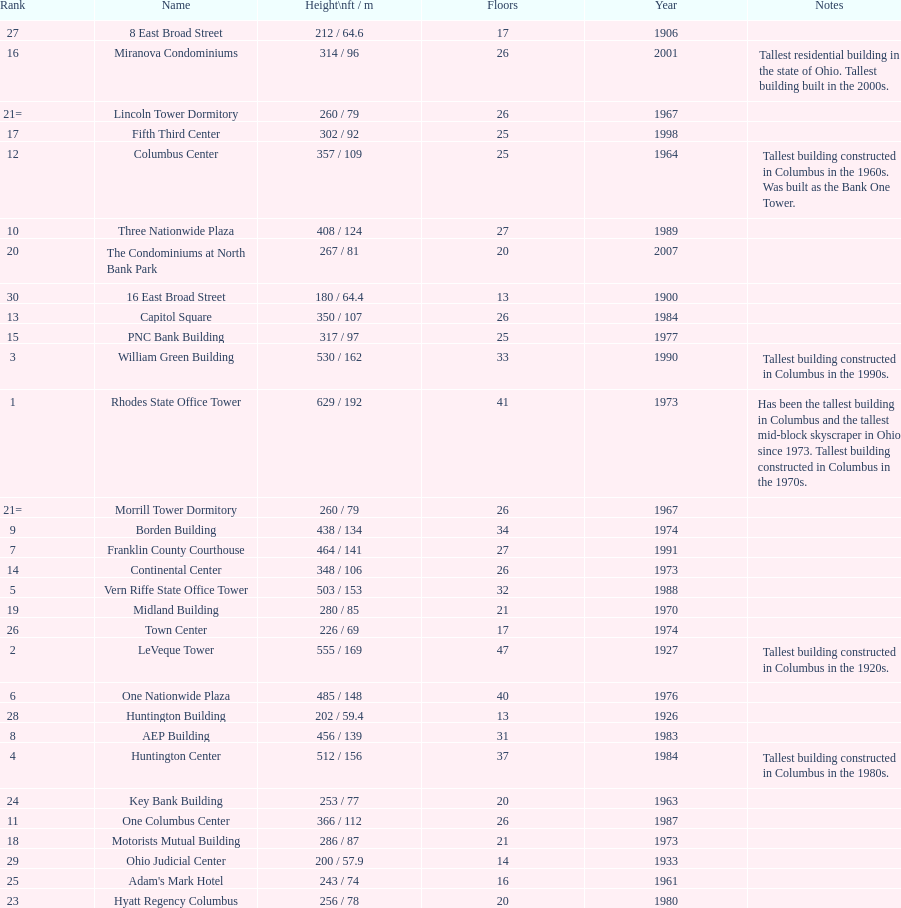What is the number of buildings under 200 ft? 1. 